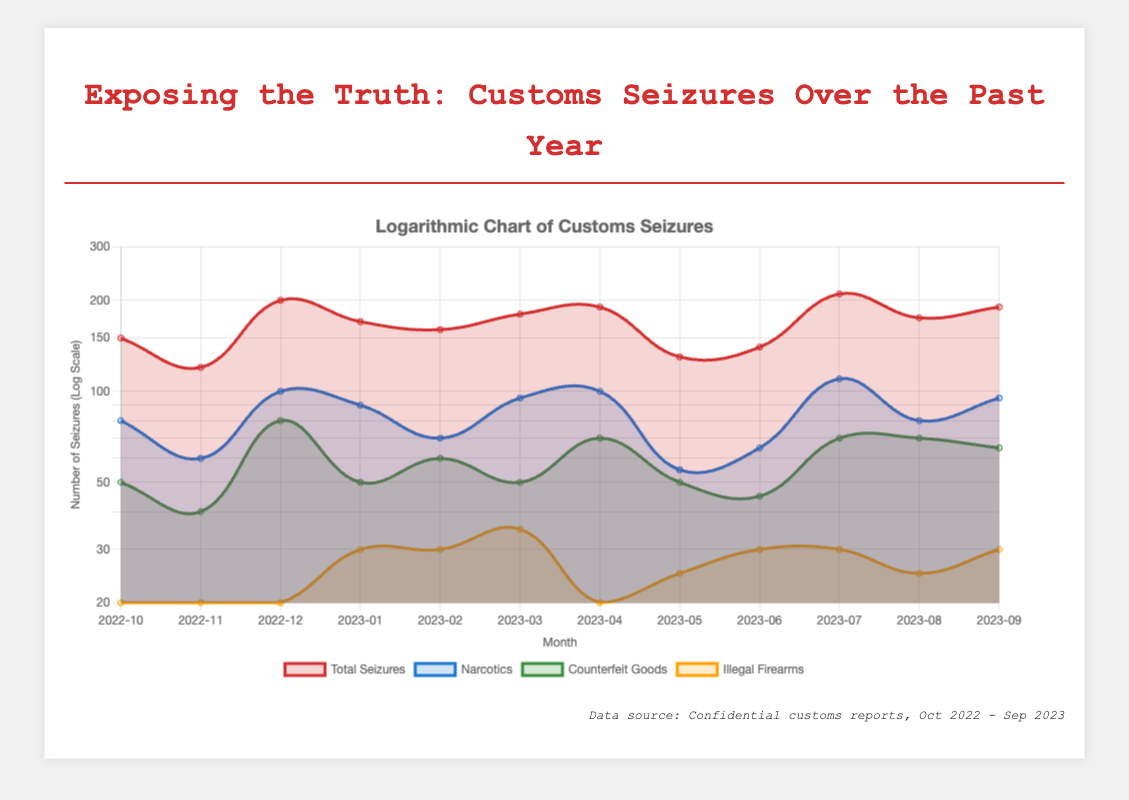What was the total number of seizures in July 2023? According to the table, the total seizures recorded for July 2023 is listed as 210.
Answer: 210 Which month had the highest number of narcotics seizures? From the data provided, the highest number of narcotics seizures occurred in July 2023 with 110 seizures.
Answer: 110 What is the average number of total seizures from October 2022 to September 2023? To calculate the average, sum the total seizures (150 + 120 + 200 + 170 + 160 + 180 + 190 + 130 + 140 + 210 + 175 + 190) = 1800, and divide by the number of months (12 months). Therefore, the average number of total seizures is 1800 / 12 = 150.
Answer: 150 Did the total seizures increase from August 2023 to September 2023? The total seizures for August 2023 is 175 and for September 2023 is 190. Since 190 is greater than 175, it indicates an increase.
Answer: Yes Which goods accounted for more than half of the total seizures in December 2022? In December 2022, total seizures were at 200. Narcotics accounted for 100 (50%), counterfeit goods for 80 (40%), and illegal firearms for 20 (10%). Since narcotics are the only goods that do not exceed half alone, none of the goods combined reached over 100 seizures.
Answer: No 